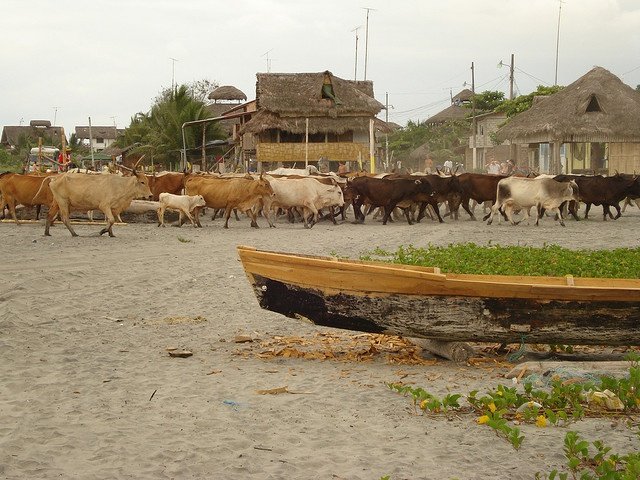Describe the objects in this image and their specific colors. I can see boat in ivory, black, olive, and maroon tones, cow in ivory, tan, olive, and maroon tones, cow in ivory, tan, and gray tones, cow in ivory, olive, maroon, and tan tones, and cow in ivory, tan, gray, and maroon tones in this image. 